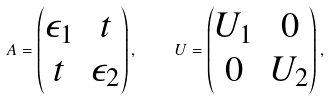Convert formula to latex. <formula><loc_0><loc_0><loc_500><loc_500>A = \begin{pmatrix} \epsilon _ { 1 } & t \\ t & \epsilon _ { 2 } \end{pmatrix} , \quad U = \begin{pmatrix} U _ { 1 } & 0 \\ 0 & U _ { 2 } \end{pmatrix} ,</formula> 